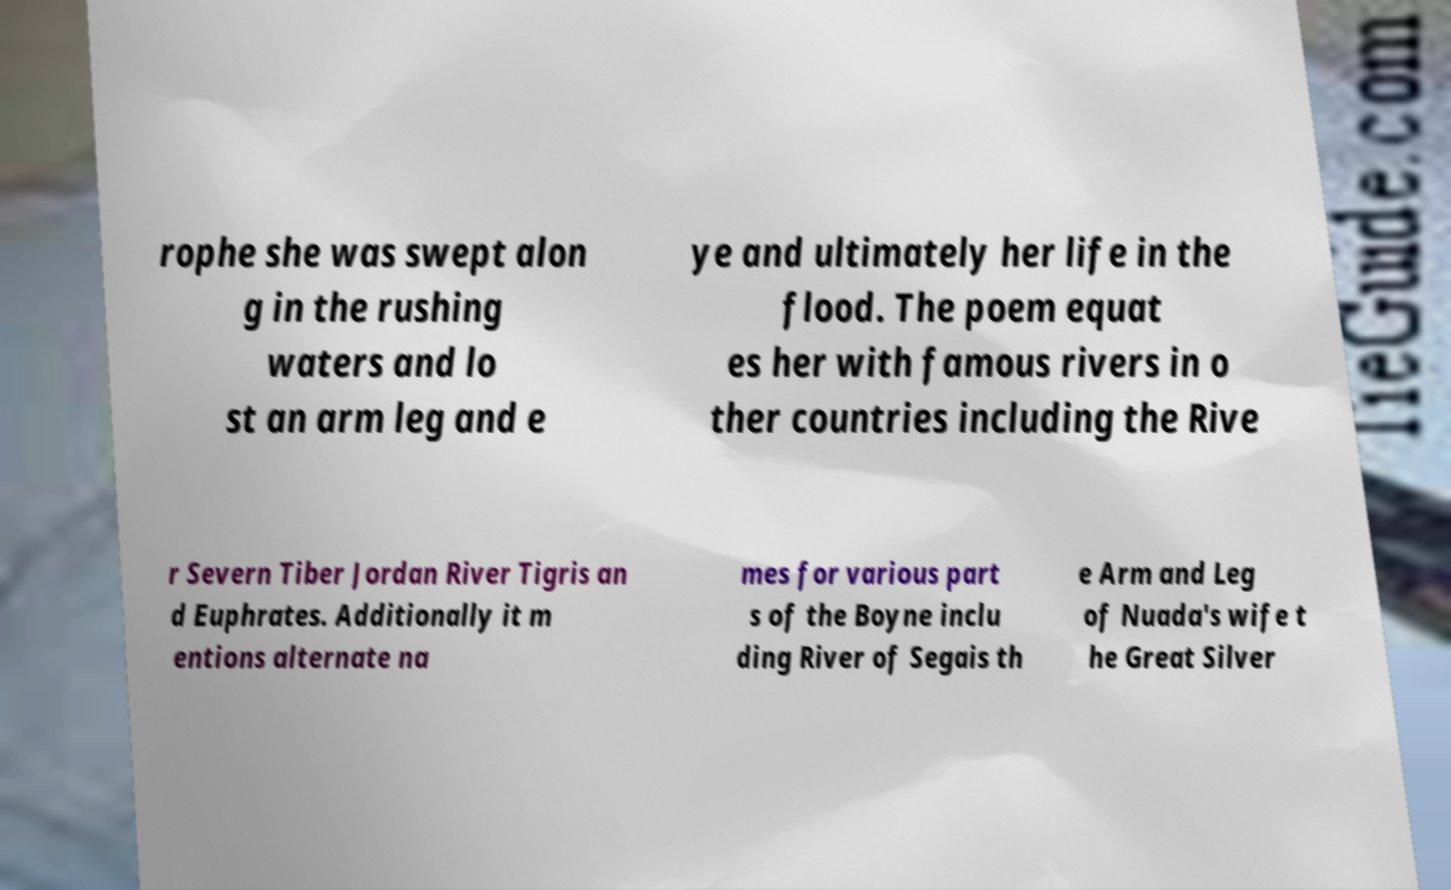Can you accurately transcribe the text from the provided image for me? rophe she was swept alon g in the rushing waters and lo st an arm leg and e ye and ultimately her life in the flood. The poem equat es her with famous rivers in o ther countries including the Rive r Severn Tiber Jordan River Tigris an d Euphrates. Additionally it m entions alternate na mes for various part s of the Boyne inclu ding River of Segais th e Arm and Leg of Nuada's wife t he Great Silver 